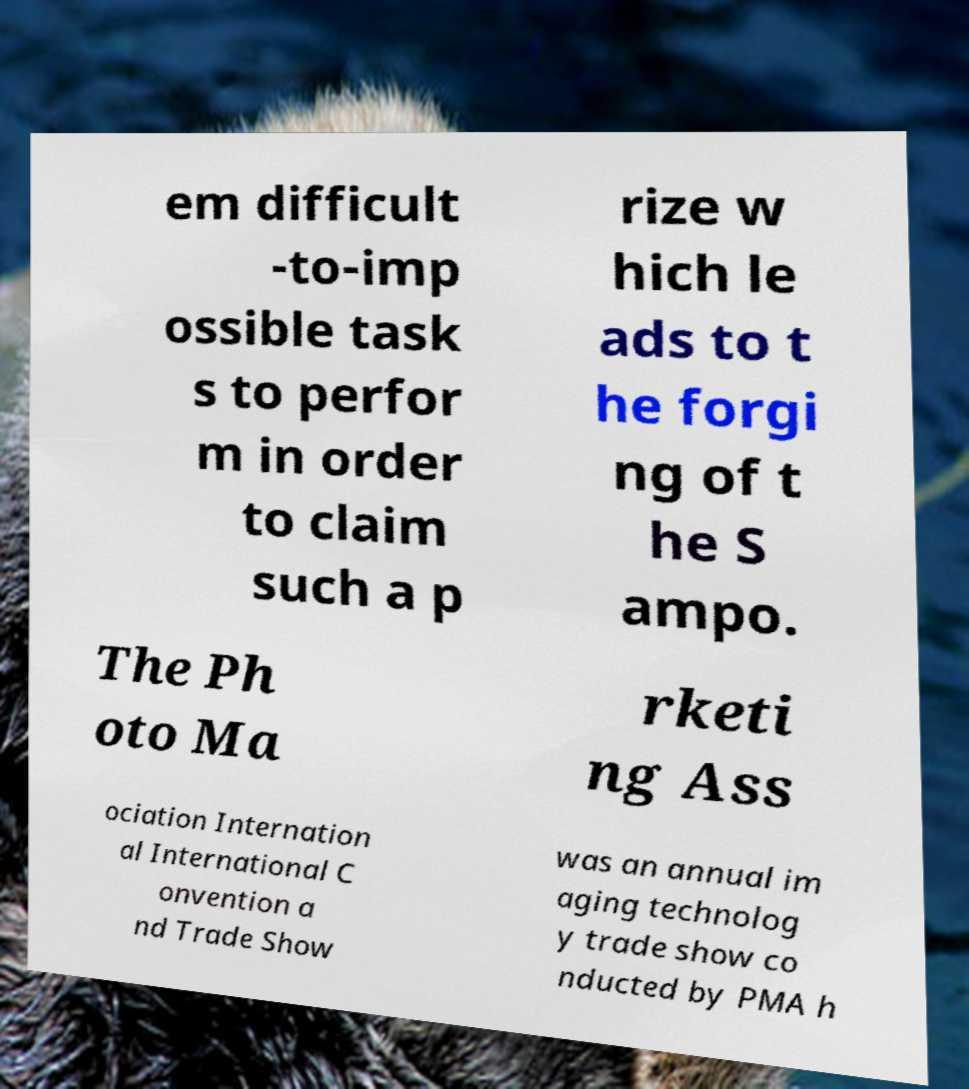Please identify and transcribe the text found in this image. em difficult -to-imp ossible task s to perfor m in order to claim such a p rize w hich le ads to t he forgi ng of t he S ampo. The Ph oto Ma rketi ng Ass ociation Internation al International C onvention a nd Trade Show was an annual im aging technolog y trade show co nducted by PMA h 